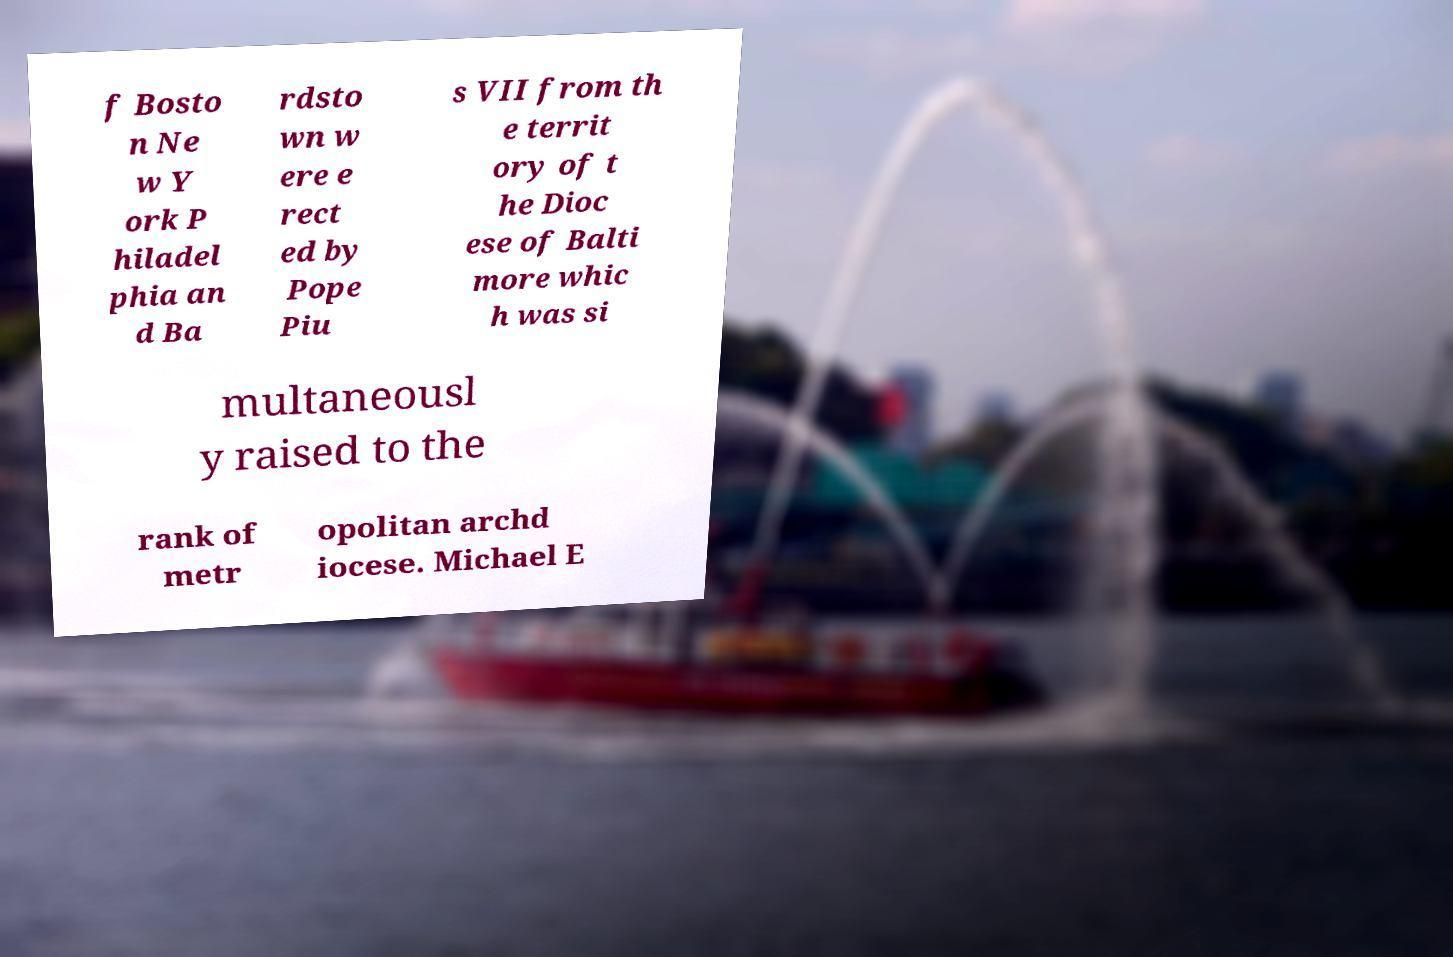Can you accurately transcribe the text from the provided image for me? f Bosto n Ne w Y ork P hiladel phia an d Ba rdsto wn w ere e rect ed by Pope Piu s VII from th e territ ory of t he Dioc ese of Balti more whic h was si multaneousl y raised to the rank of metr opolitan archd iocese. Michael E 